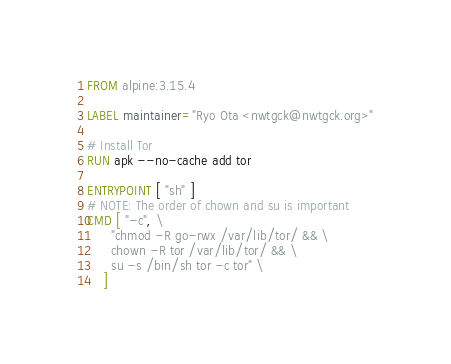<code> <loc_0><loc_0><loc_500><loc_500><_Dockerfile_>FROM alpine:3.15.4

LABEL maintainer="Ryo Ota <nwtgck@nwtgck.org>"

# Install Tor
RUN apk --no-cache add tor

ENTRYPOINT [ "sh" ]
# NOTE: The order of chown and su is important
CMD [ "-c", \
      "chmod -R go-rwx /var/lib/tor/ && \
      chown -R tor /var/lib/tor/ && \
      su -s /bin/sh tor -c tor" \
    ]
</code> 